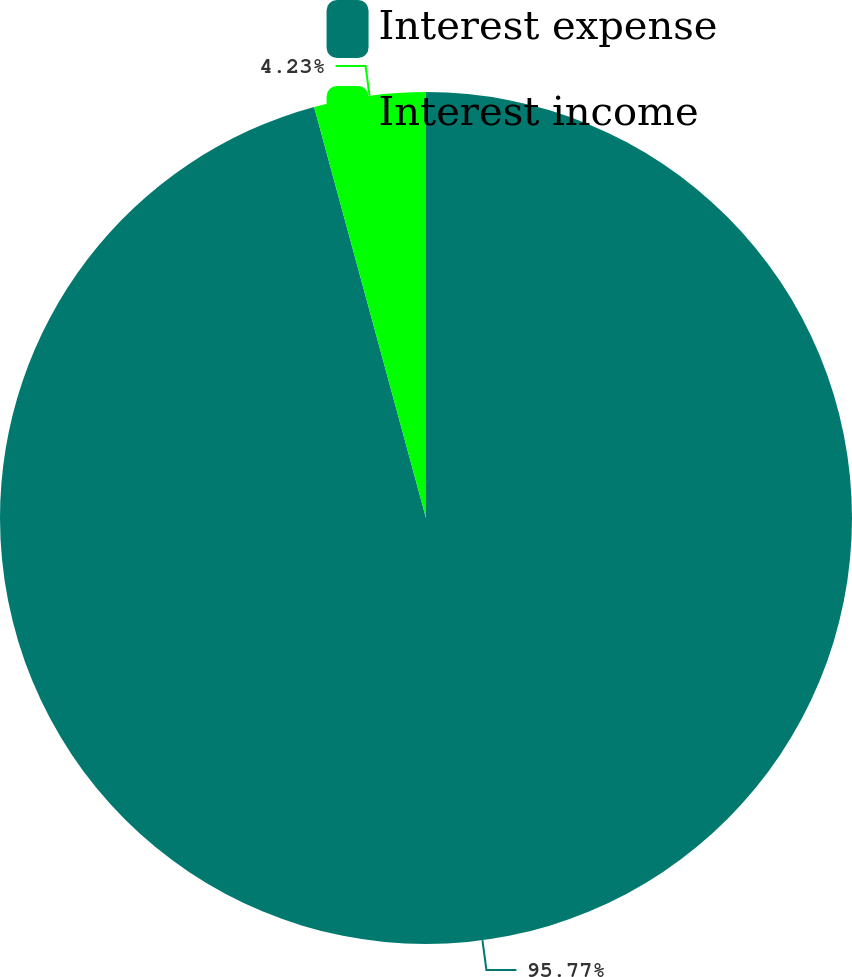Convert chart. <chart><loc_0><loc_0><loc_500><loc_500><pie_chart><fcel>Interest expense<fcel>Interest income<nl><fcel>95.77%<fcel>4.23%<nl></chart> 